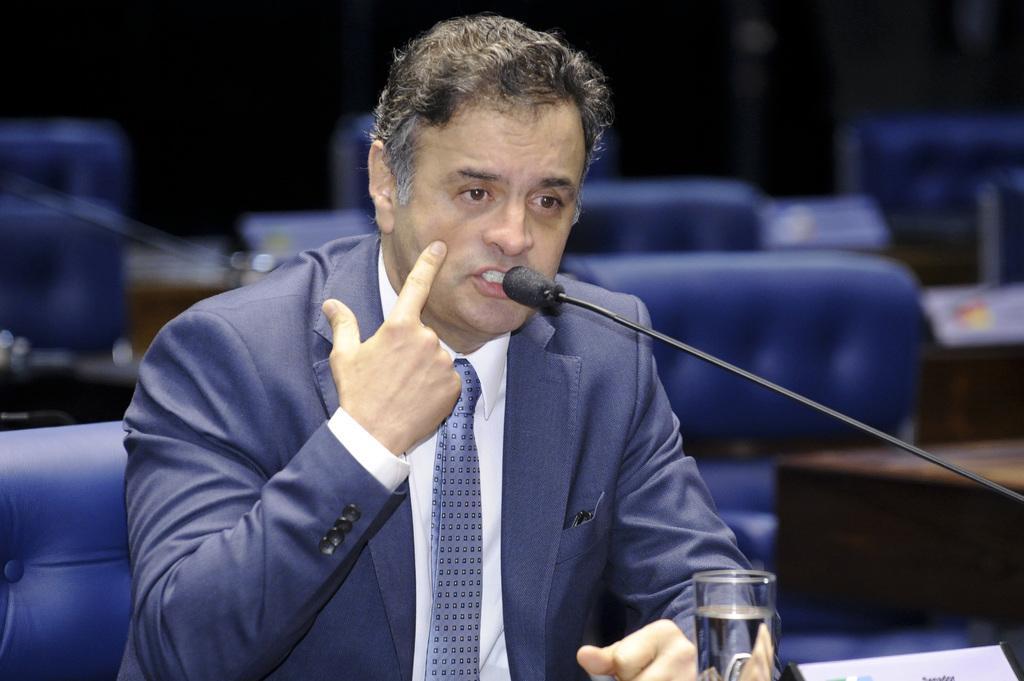Please provide a concise description of this image. In this picture there is a man in the center of the image and there is a mic and a glass of water in front of him and there are chairs behind him. 